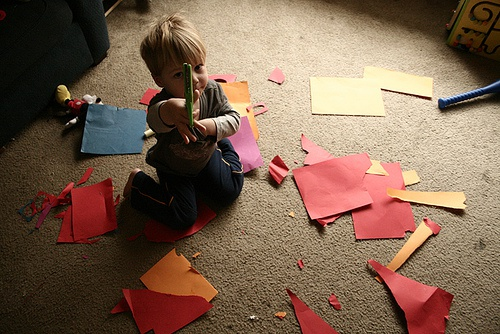Describe the objects in this image and their specific colors. I can see people in black, maroon, and gray tones, baseball bat in black, navy, gray, and darkgray tones, and scissors in black, darkgreen, and olive tones in this image. 